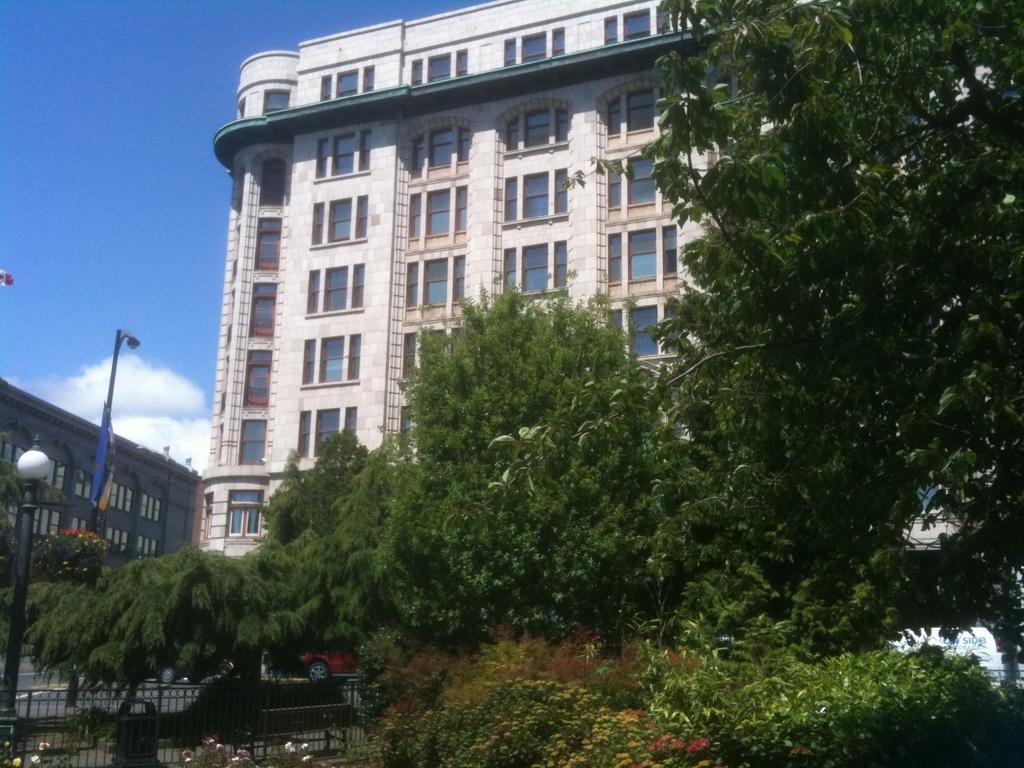What type of vegetation can be seen in the image? There are trees in the image. What type of structure is present in the image? There is a fence in the image. What type of vehicles can be seen on the road in the image? There are cars on the road in the image. What type of structures are present to provide illumination in the image? There are light poles in the image. What type of signage is present in the image? There is a banner in the image. What type of man-made structures can be seen in the image? There are buildings in the image. What part of the natural environment is visible in the background of the image? The sky is visible in the background of the image. What type of weather can be inferred from the image? The presence of clouds in the sky suggests that the weather might be partly cloudy. What type of ice is being taught on the tongue in the image? There is no ice or teaching activity involving a tongue present in the image. 